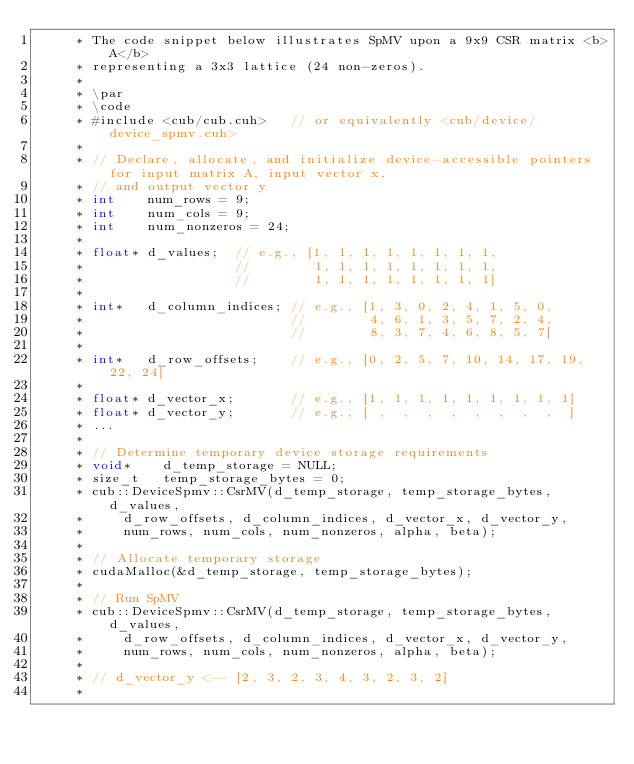Convert code to text. <code><loc_0><loc_0><loc_500><loc_500><_Cuda_>     * The code snippet below illustrates SpMV upon a 9x9 CSR matrix <b>A</b>
     * representing a 3x3 lattice (24 non-zeros).
     *
     * \par
     * \code
     * #include <cub/cub.cuh>   // or equivalently <cub/device/device_spmv.cuh>
     *
     * // Declare, allocate, and initialize device-accessible pointers for input matrix A, input vector x,
     * // and output vector y
     * int    num_rows = 9;
     * int    num_cols = 9;
     * int    num_nonzeros = 24;
     *
     * float* d_values;  // e.g., [1, 1, 1, 1, 1, 1, 1, 1,
     *                   //        1, 1, 1, 1, 1, 1, 1, 1,
     *                   //        1, 1, 1, 1, 1, 1, 1, 1]
     *
     * int*   d_column_indices; // e.g., [1, 3, 0, 2, 4, 1, 5, 0,
     *                          //        4, 6, 1, 3, 5, 7, 2, 4,
     *                          //        8, 3, 7, 4, 6, 8, 5, 7]
     *
     * int*   d_row_offsets;    // e.g., [0, 2, 5, 7, 10, 14, 17, 19, 22, 24]
     *
     * float* d_vector_x;       // e.g., [1, 1, 1, 1, 1, 1, 1, 1, 1]
     * float* d_vector_y;       // e.g., [ ,  ,  ,  ,  ,  ,  ,  ,  ]
     * ...
     *
     * // Determine temporary device storage requirements
     * void*    d_temp_storage = NULL;
     * size_t   temp_storage_bytes = 0;
     * cub::DeviceSpmv::CsrMV(d_temp_storage, temp_storage_bytes, d_values,
     *     d_row_offsets, d_column_indices, d_vector_x, d_vector_y,
     *     num_rows, num_cols, num_nonzeros, alpha, beta);
     *
     * // Allocate temporary storage
     * cudaMalloc(&d_temp_storage, temp_storage_bytes);
     *
     * // Run SpMV
     * cub::DeviceSpmv::CsrMV(d_temp_storage, temp_storage_bytes, d_values,
     *     d_row_offsets, d_column_indices, d_vector_x, d_vector_y,
     *     num_rows, num_cols, num_nonzeros, alpha, beta);
     *
     * // d_vector_y <-- [2, 3, 2, 3, 4, 3, 2, 3, 2]
     *</code> 